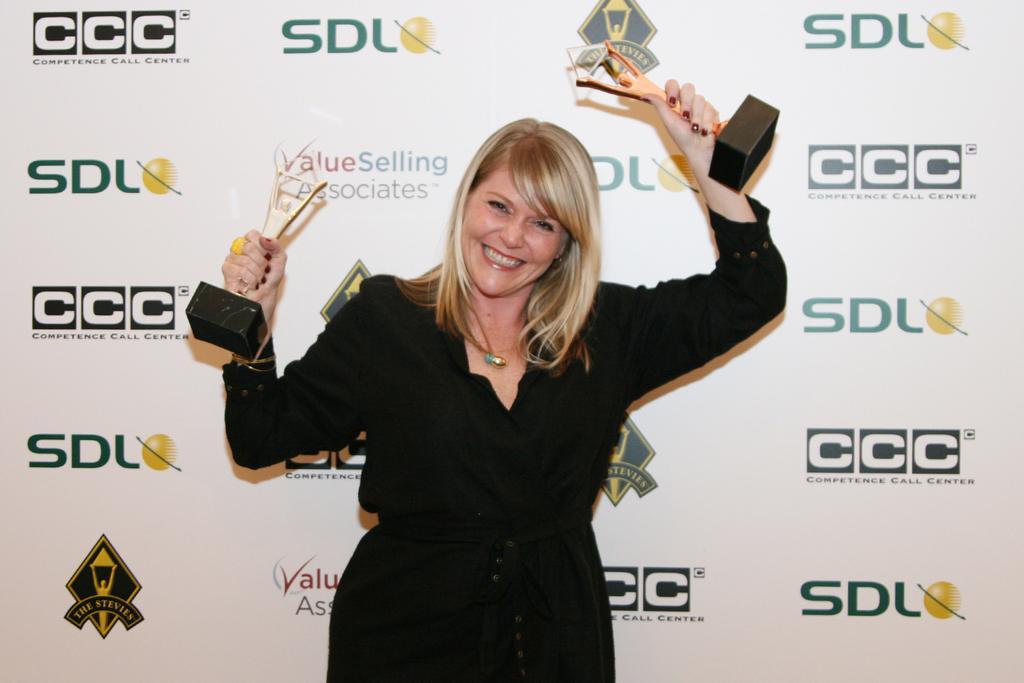Could you give a brief overview of what you see in this image? In the center of the image we can see a woman standing holding the mementos. On the backside we can see a board with some text on it. 